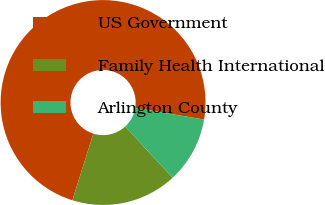Convert chart. <chart><loc_0><loc_0><loc_500><loc_500><pie_chart><fcel>US Government<fcel>Family Health International<fcel>Arlington County<nl><fcel>72.82%<fcel>16.71%<fcel>10.47%<nl></chart> 